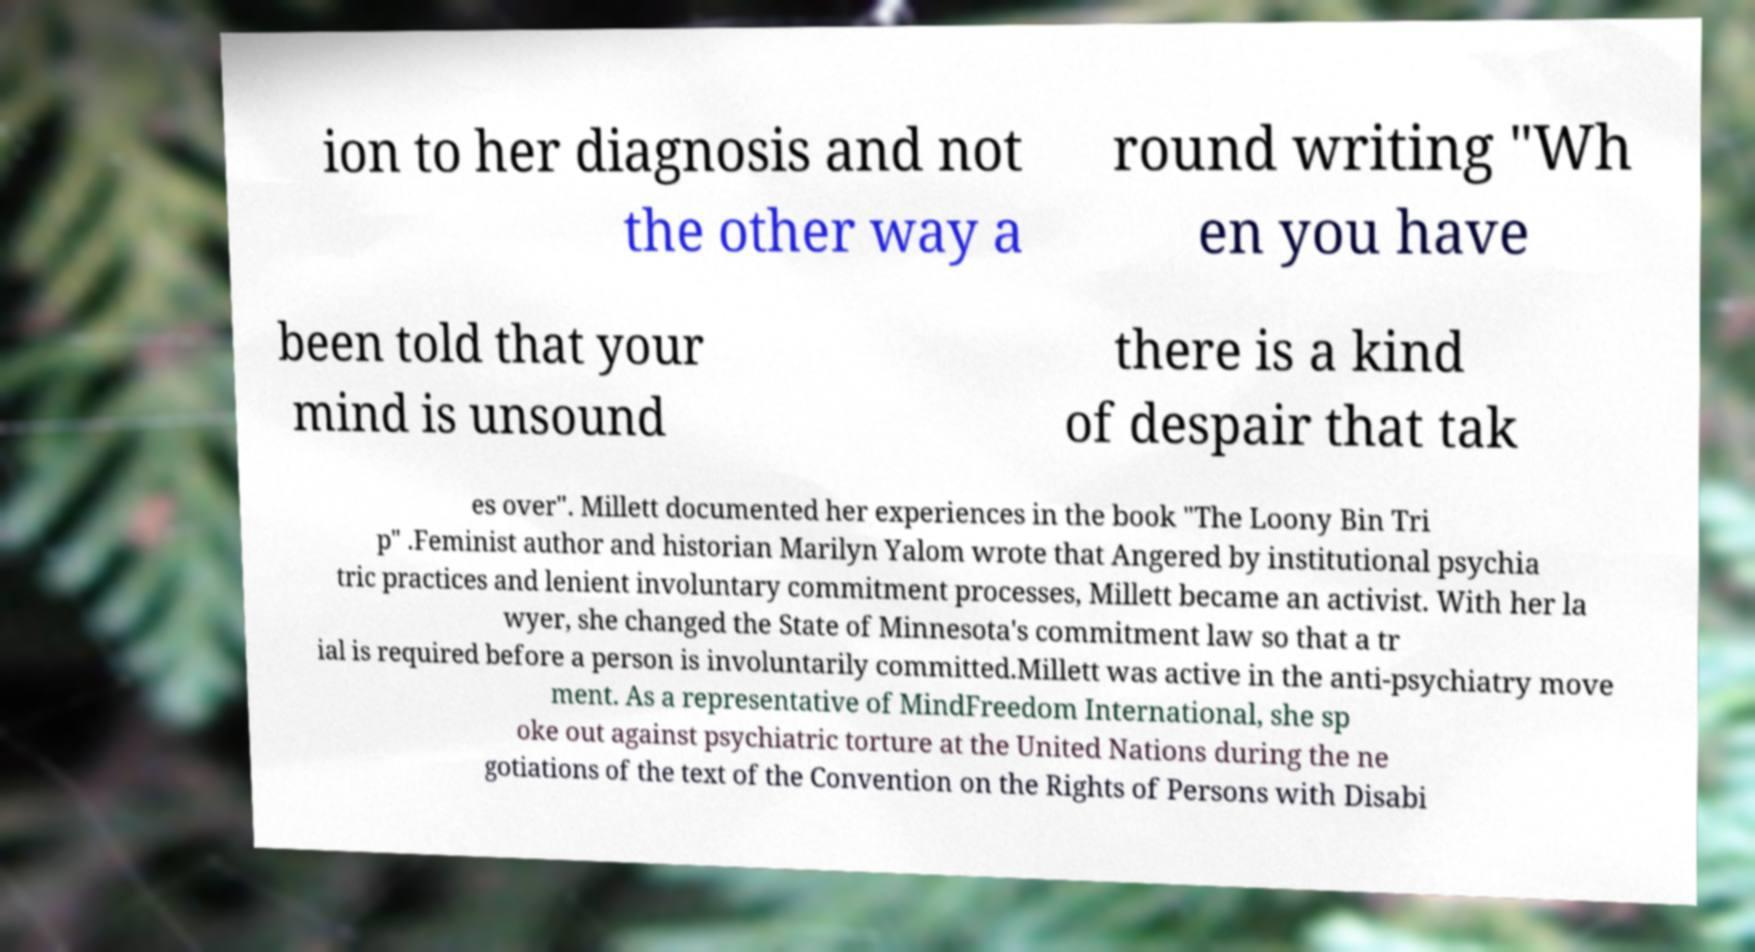For documentation purposes, I need the text within this image transcribed. Could you provide that? ion to her diagnosis and not the other way a round writing "Wh en you have been told that your mind is unsound there is a kind of despair that tak es over". Millett documented her experiences in the book "The Loony Bin Tri p" .Feminist author and historian Marilyn Yalom wrote that Angered by institutional psychia tric practices and lenient involuntary commitment processes, Millett became an activist. With her la wyer, she changed the State of Minnesota's commitment law so that a tr ial is required before a person is involuntarily committed.Millett was active in the anti-psychiatry move ment. As a representative of MindFreedom International, she sp oke out against psychiatric torture at the United Nations during the ne gotiations of the text of the Convention on the Rights of Persons with Disabi 